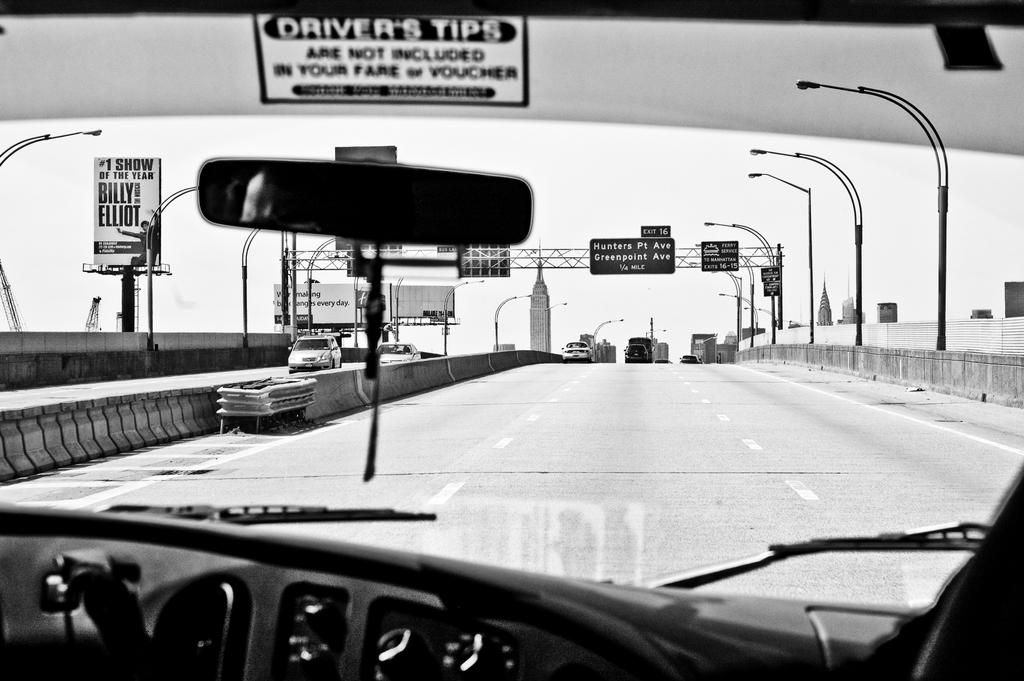What is the color scheme of the image? The image is black and white. What can be seen on the road in the image? There are motor vehicles on the road. What type of structures are present along the road? Street poles, street lights, advertisement boards, and name boards are present in the image. What type of security feature is visible in the image? Iron grills are visible in the image. What part of the natural environment is visible in the image? The sky is visible in the image. How many crows are sitting on the advertisement boards in the image? There are no crows present in the image; it only features motor vehicles, street poles, street lights, advertisement boards, name boards, iron grills, and the sky. What type of hair product is being advertised on the name boards in the image? There is no hair product being advertised on the name boards in the image; the name boards contain text and images related to businesses or services. 